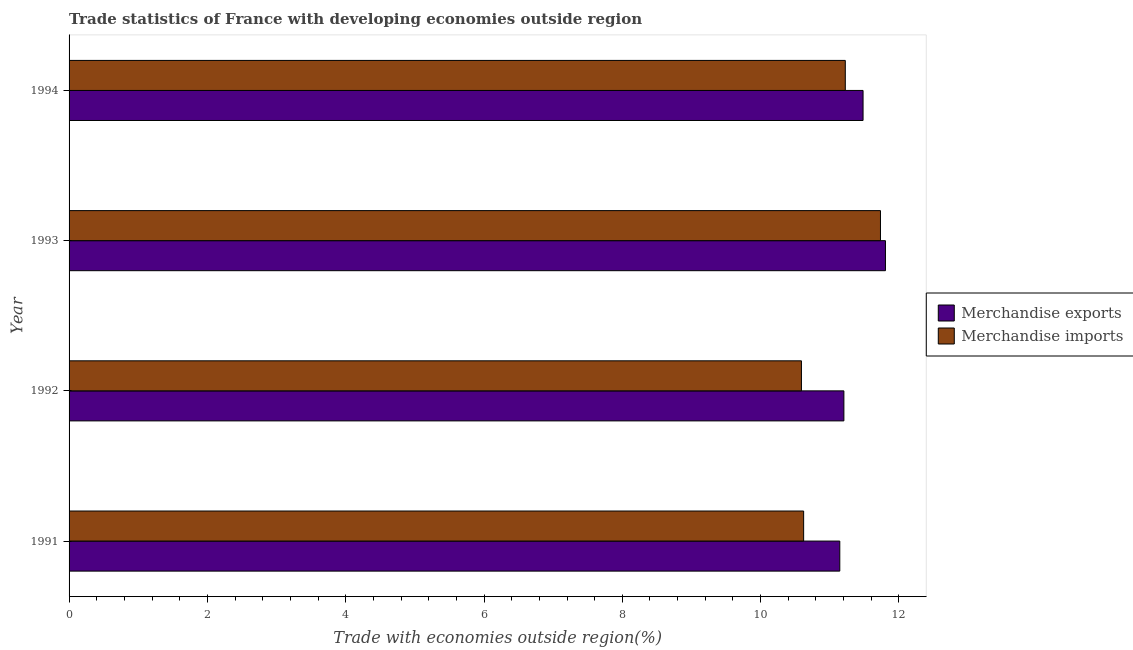How many different coloured bars are there?
Give a very brief answer. 2. How many groups of bars are there?
Offer a terse response. 4. Are the number of bars per tick equal to the number of legend labels?
Your answer should be compact. Yes. How many bars are there on the 3rd tick from the bottom?
Give a very brief answer. 2. What is the label of the 3rd group of bars from the top?
Provide a succinct answer. 1992. What is the merchandise exports in 1994?
Offer a terse response. 11.48. Across all years, what is the maximum merchandise exports?
Your answer should be compact. 11.8. Across all years, what is the minimum merchandise imports?
Keep it short and to the point. 10.59. What is the total merchandise exports in the graph?
Keep it short and to the point. 45.63. What is the difference between the merchandise imports in 1992 and that in 1993?
Your response must be concise. -1.14. What is the difference between the merchandise imports in 1992 and the merchandise exports in 1994?
Offer a very short reply. -0.89. What is the average merchandise exports per year?
Your response must be concise. 11.41. In the year 1991, what is the difference between the merchandise imports and merchandise exports?
Your answer should be very brief. -0.52. In how many years, is the merchandise exports greater than 9.2 %?
Your answer should be very brief. 4. What is the ratio of the merchandise imports in 1992 to that in 1994?
Provide a short and direct response. 0.94. What is the difference between the highest and the second highest merchandise imports?
Provide a succinct answer. 0.51. What is the difference between the highest and the lowest merchandise exports?
Provide a short and direct response. 0.66. Is the sum of the merchandise imports in 1991 and 1993 greater than the maximum merchandise exports across all years?
Your response must be concise. Yes. What does the 1st bar from the bottom in 1992 represents?
Your answer should be very brief. Merchandise exports. Are all the bars in the graph horizontal?
Your response must be concise. Yes. Are the values on the major ticks of X-axis written in scientific E-notation?
Your answer should be compact. No. Does the graph contain any zero values?
Your response must be concise. No. Does the graph contain grids?
Ensure brevity in your answer.  No. How are the legend labels stacked?
Keep it short and to the point. Vertical. What is the title of the graph?
Provide a short and direct response. Trade statistics of France with developing economies outside region. Does "Grants" appear as one of the legend labels in the graph?
Provide a succinct answer. No. What is the label or title of the X-axis?
Make the answer very short. Trade with economies outside region(%). What is the label or title of the Y-axis?
Provide a short and direct response. Year. What is the Trade with economies outside region(%) of Merchandise exports in 1991?
Offer a very short reply. 11.14. What is the Trade with economies outside region(%) in Merchandise imports in 1991?
Offer a very short reply. 10.62. What is the Trade with economies outside region(%) of Merchandise exports in 1992?
Your answer should be compact. 11.2. What is the Trade with economies outside region(%) in Merchandise imports in 1992?
Give a very brief answer. 10.59. What is the Trade with economies outside region(%) in Merchandise exports in 1993?
Your answer should be compact. 11.8. What is the Trade with economies outside region(%) in Merchandise imports in 1993?
Your response must be concise. 11.73. What is the Trade with economies outside region(%) of Merchandise exports in 1994?
Your answer should be compact. 11.48. What is the Trade with economies outside region(%) in Merchandise imports in 1994?
Give a very brief answer. 11.22. Across all years, what is the maximum Trade with economies outside region(%) of Merchandise exports?
Keep it short and to the point. 11.8. Across all years, what is the maximum Trade with economies outside region(%) of Merchandise imports?
Make the answer very short. 11.73. Across all years, what is the minimum Trade with economies outside region(%) in Merchandise exports?
Offer a very short reply. 11.14. Across all years, what is the minimum Trade with economies outside region(%) in Merchandise imports?
Provide a short and direct response. 10.59. What is the total Trade with economies outside region(%) of Merchandise exports in the graph?
Your response must be concise. 45.63. What is the total Trade with economies outside region(%) of Merchandise imports in the graph?
Provide a succinct answer. 44.17. What is the difference between the Trade with economies outside region(%) of Merchandise exports in 1991 and that in 1992?
Provide a succinct answer. -0.06. What is the difference between the Trade with economies outside region(%) of Merchandise imports in 1991 and that in 1992?
Keep it short and to the point. 0.03. What is the difference between the Trade with economies outside region(%) of Merchandise exports in 1991 and that in 1993?
Ensure brevity in your answer.  -0.66. What is the difference between the Trade with economies outside region(%) of Merchandise imports in 1991 and that in 1993?
Provide a short and direct response. -1.11. What is the difference between the Trade with economies outside region(%) of Merchandise exports in 1991 and that in 1994?
Keep it short and to the point. -0.34. What is the difference between the Trade with economies outside region(%) of Merchandise imports in 1991 and that in 1994?
Keep it short and to the point. -0.6. What is the difference between the Trade with economies outside region(%) in Merchandise exports in 1992 and that in 1993?
Offer a terse response. -0.6. What is the difference between the Trade with economies outside region(%) of Merchandise imports in 1992 and that in 1993?
Provide a succinct answer. -1.14. What is the difference between the Trade with economies outside region(%) of Merchandise exports in 1992 and that in 1994?
Your answer should be very brief. -0.28. What is the difference between the Trade with economies outside region(%) of Merchandise imports in 1992 and that in 1994?
Give a very brief answer. -0.63. What is the difference between the Trade with economies outside region(%) of Merchandise exports in 1993 and that in 1994?
Offer a terse response. 0.32. What is the difference between the Trade with economies outside region(%) in Merchandise imports in 1993 and that in 1994?
Offer a terse response. 0.51. What is the difference between the Trade with economies outside region(%) in Merchandise exports in 1991 and the Trade with economies outside region(%) in Merchandise imports in 1992?
Offer a terse response. 0.55. What is the difference between the Trade with economies outside region(%) of Merchandise exports in 1991 and the Trade with economies outside region(%) of Merchandise imports in 1993?
Provide a succinct answer. -0.59. What is the difference between the Trade with economies outside region(%) in Merchandise exports in 1991 and the Trade with economies outside region(%) in Merchandise imports in 1994?
Offer a very short reply. -0.08. What is the difference between the Trade with economies outside region(%) of Merchandise exports in 1992 and the Trade with economies outside region(%) of Merchandise imports in 1993?
Your answer should be very brief. -0.53. What is the difference between the Trade with economies outside region(%) in Merchandise exports in 1992 and the Trade with economies outside region(%) in Merchandise imports in 1994?
Make the answer very short. -0.02. What is the difference between the Trade with economies outside region(%) in Merchandise exports in 1993 and the Trade with economies outside region(%) in Merchandise imports in 1994?
Offer a terse response. 0.58. What is the average Trade with economies outside region(%) of Merchandise exports per year?
Provide a short and direct response. 11.41. What is the average Trade with economies outside region(%) in Merchandise imports per year?
Your response must be concise. 11.04. In the year 1991, what is the difference between the Trade with economies outside region(%) in Merchandise exports and Trade with economies outside region(%) in Merchandise imports?
Your answer should be very brief. 0.52. In the year 1992, what is the difference between the Trade with economies outside region(%) of Merchandise exports and Trade with economies outside region(%) of Merchandise imports?
Offer a terse response. 0.61. In the year 1993, what is the difference between the Trade with economies outside region(%) in Merchandise exports and Trade with economies outside region(%) in Merchandise imports?
Your answer should be compact. 0.07. In the year 1994, what is the difference between the Trade with economies outside region(%) of Merchandise exports and Trade with economies outside region(%) of Merchandise imports?
Provide a succinct answer. 0.26. What is the ratio of the Trade with economies outside region(%) in Merchandise exports in 1991 to that in 1992?
Provide a succinct answer. 0.99. What is the ratio of the Trade with economies outside region(%) of Merchandise imports in 1991 to that in 1992?
Your answer should be very brief. 1. What is the ratio of the Trade with economies outside region(%) in Merchandise exports in 1991 to that in 1993?
Offer a very short reply. 0.94. What is the ratio of the Trade with economies outside region(%) of Merchandise imports in 1991 to that in 1993?
Offer a very short reply. 0.91. What is the ratio of the Trade with economies outside region(%) of Merchandise exports in 1991 to that in 1994?
Ensure brevity in your answer.  0.97. What is the ratio of the Trade with economies outside region(%) in Merchandise imports in 1991 to that in 1994?
Ensure brevity in your answer.  0.95. What is the ratio of the Trade with economies outside region(%) in Merchandise exports in 1992 to that in 1993?
Make the answer very short. 0.95. What is the ratio of the Trade with economies outside region(%) in Merchandise imports in 1992 to that in 1993?
Offer a terse response. 0.9. What is the ratio of the Trade with economies outside region(%) in Merchandise exports in 1992 to that in 1994?
Make the answer very short. 0.98. What is the ratio of the Trade with economies outside region(%) in Merchandise imports in 1992 to that in 1994?
Keep it short and to the point. 0.94. What is the ratio of the Trade with economies outside region(%) of Merchandise exports in 1993 to that in 1994?
Provide a succinct answer. 1.03. What is the ratio of the Trade with economies outside region(%) of Merchandise imports in 1993 to that in 1994?
Your response must be concise. 1.05. What is the difference between the highest and the second highest Trade with economies outside region(%) of Merchandise exports?
Ensure brevity in your answer.  0.32. What is the difference between the highest and the second highest Trade with economies outside region(%) in Merchandise imports?
Offer a terse response. 0.51. What is the difference between the highest and the lowest Trade with economies outside region(%) in Merchandise exports?
Your answer should be compact. 0.66. What is the difference between the highest and the lowest Trade with economies outside region(%) of Merchandise imports?
Your answer should be very brief. 1.14. 